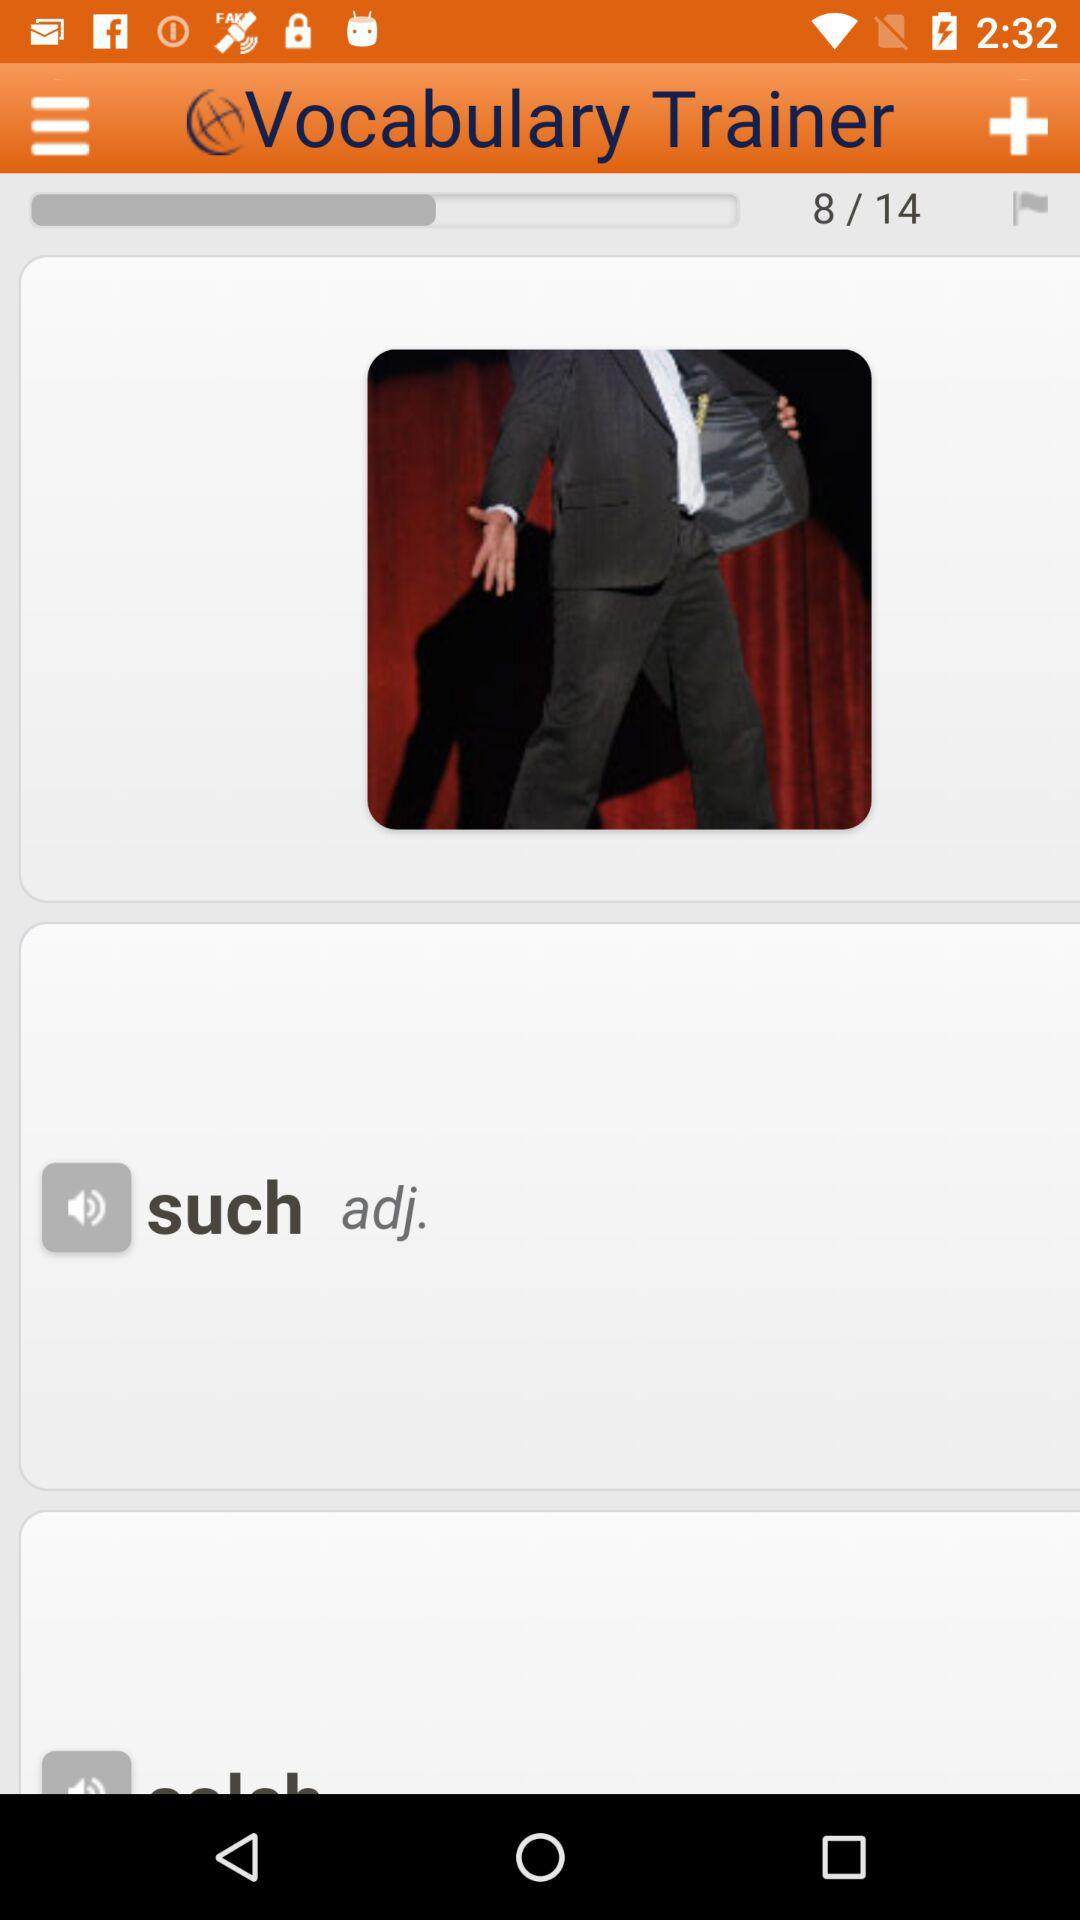What is the total vocabulary given? The given total vocabulary is 14. 